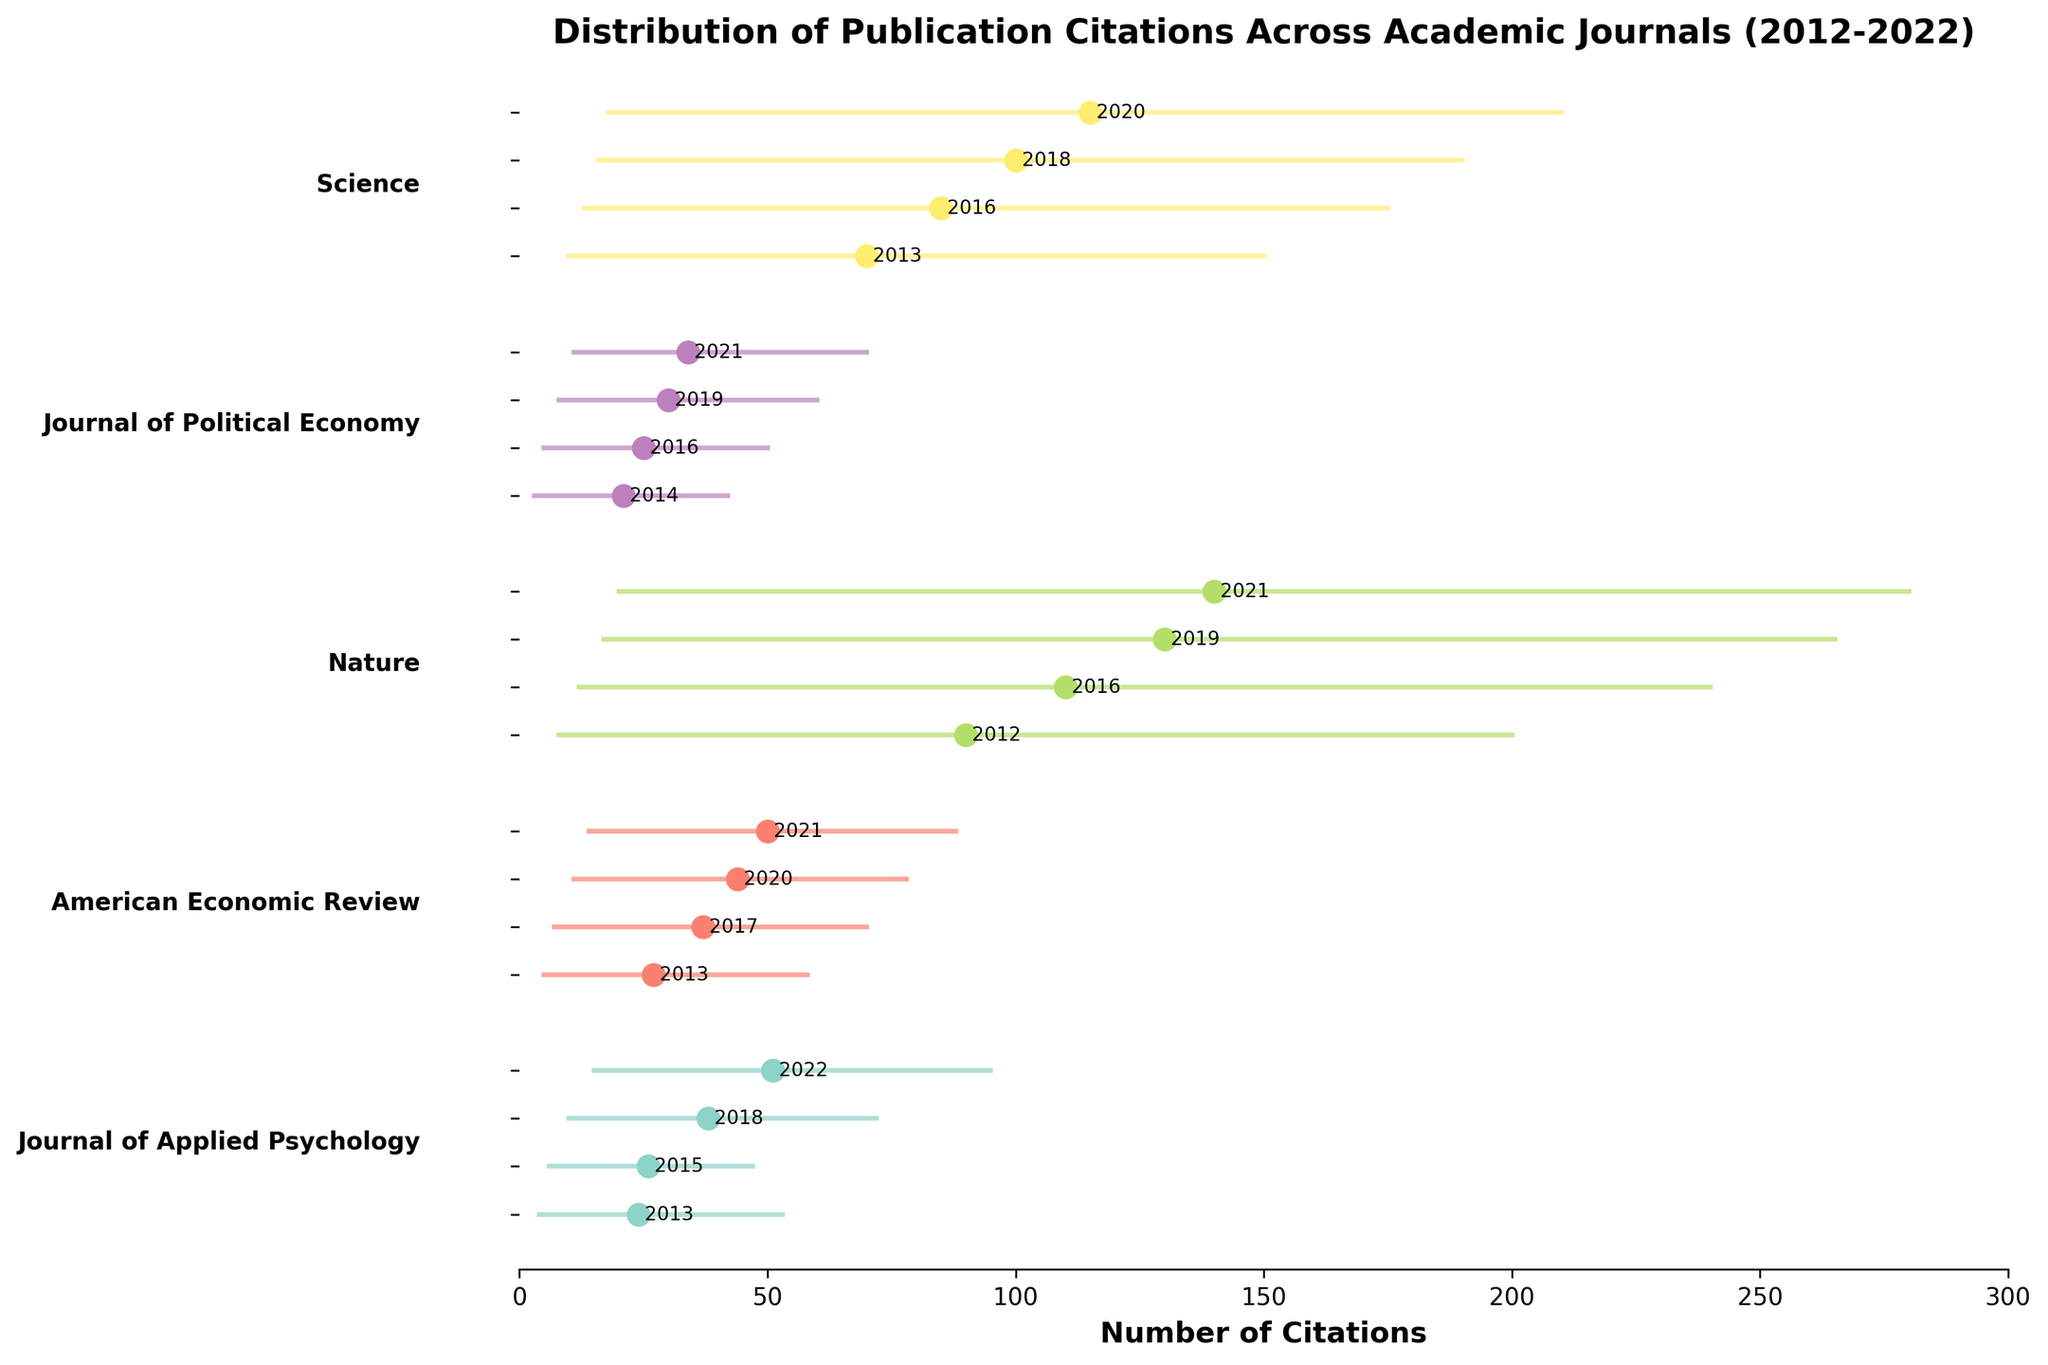Which journal has the highest average citation in the most recent year shown? The chart shows that for each journal, the dot corresponding to the highest number of citations in the most recent year is at the top of each vertical line. For the most recent year shown, "Nature" has the highest average citation based on its corresponding dot.
Answer: Nature What is the range of citations for Science in 2020? The figure uses a horizontal line to indicate the range of citations for each year and each journal. For Science in 2020, the line starts at 18 (min) and ends at 210 (max). Hence, the range is 210 - 18.
Answer: 192 Between "Journal of Applied Psychology" and "American Economic Review," which journal shows a greater increase in average citations from their earliest to their latest years? The figure shows the average citations as dots along each journal's range line. For "Journal of Applied Psychology," we see the average citations increase from 24 to 51 (an increase of 27). For "American Economic Review," the increase is from 27 to 50 (an increase of 23). Thus, "Journal of Applied Psychology" shows a greater increase.
Answer: Journal of Applied Psychology How have the minimum citations for "Journal of Political Economy" changed over the years shown? The minimum citation values are the left endpoints of the horizontal lines. Observing the positions of these endpoints for "Journal of Political Economy," we see: 3 (2014), 5 (2016), 8 (2019), and 11 (2021). Therefore, the minimum citations have increased steadily over the years.
Answer: Increased steadily Which journal has the widest citation range in its most recent year? To find the widest range, we need to look at the longest horizontal line for the most recent year for each journal. For the most recent years shown, "Nature" reaches from a minimum of 20 to a maximum of 280, giving the widest range of 260 citations.
Answer: Nature Which year did "Nature" have the highest average citations? The average citation values are indicated by the dots on the line for each journal and each year. For "Nature," the dots show the following average citations: 90 (2012), 110 (2016), 130 (2019), and 140 (2021). Thus, the highest average citation year is 2021.
Answer: 2021 Are there any journals where the maximum citations have decreased over time? We search for horizontal lines where the right endpoint (max citations) moves leftwards over time. None of the journals show a decreasing trend in maximum citations in the data provided.
Answer: No 